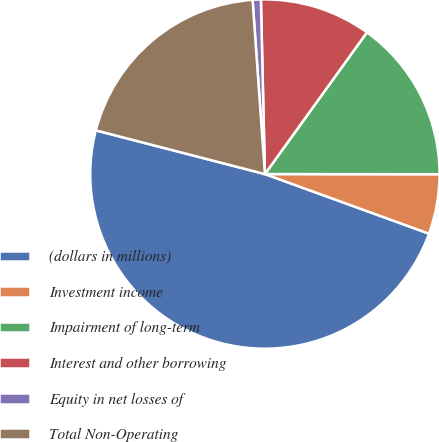Convert chart. <chart><loc_0><loc_0><loc_500><loc_500><pie_chart><fcel>(dollars in millions)<fcel>Investment income<fcel>Impairment of long-term<fcel>Interest and other borrowing<fcel>Equity in net losses of<fcel>Total Non-Operating<nl><fcel>48.48%<fcel>5.53%<fcel>15.08%<fcel>10.3%<fcel>0.76%<fcel>19.85%<nl></chart> 